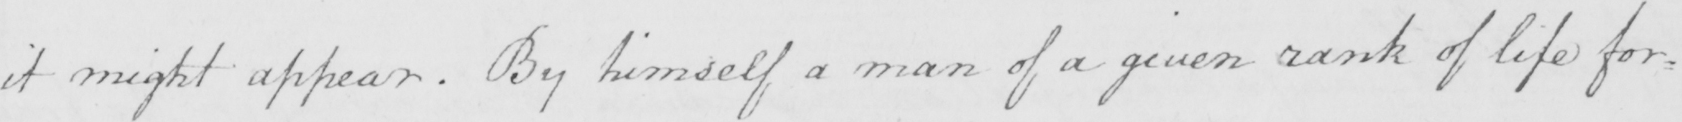What is written in this line of handwriting? it might appear . By himself a man of a given rank of life for= 